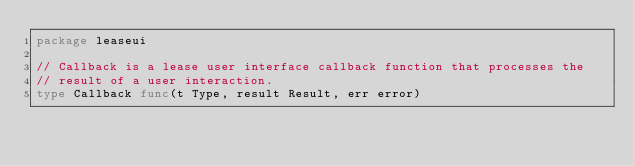<code> <loc_0><loc_0><loc_500><loc_500><_Go_>package leaseui

// Callback is a lease user interface callback function that processes the
// result of a user interaction.
type Callback func(t Type, result Result, err error)
</code> 